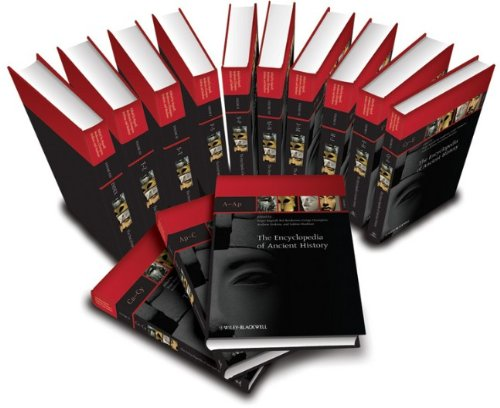Is this book related to Reference? Yes, 'The Encyclopedia of Ancient History' is indeed a reference book. It is crafted to aid users in finding detailed and well-researched information on various topics pertaining to ancient history. 